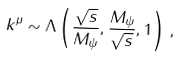Convert formula to latex. <formula><loc_0><loc_0><loc_500><loc_500>k ^ { \mu } \sim \Lambda \left ( \frac { \sqrt { s } } { M _ { \psi } } , \frac { M _ { \psi } } { \sqrt { s } } , 1 \right ) \, ,</formula> 